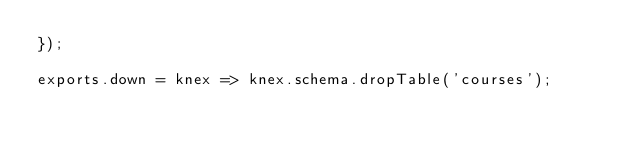<code> <loc_0><loc_0><loc_500><loc_500><_JavaScript_>});

exports.down = knex => knex.schema.dropTable('courses');
</code> 